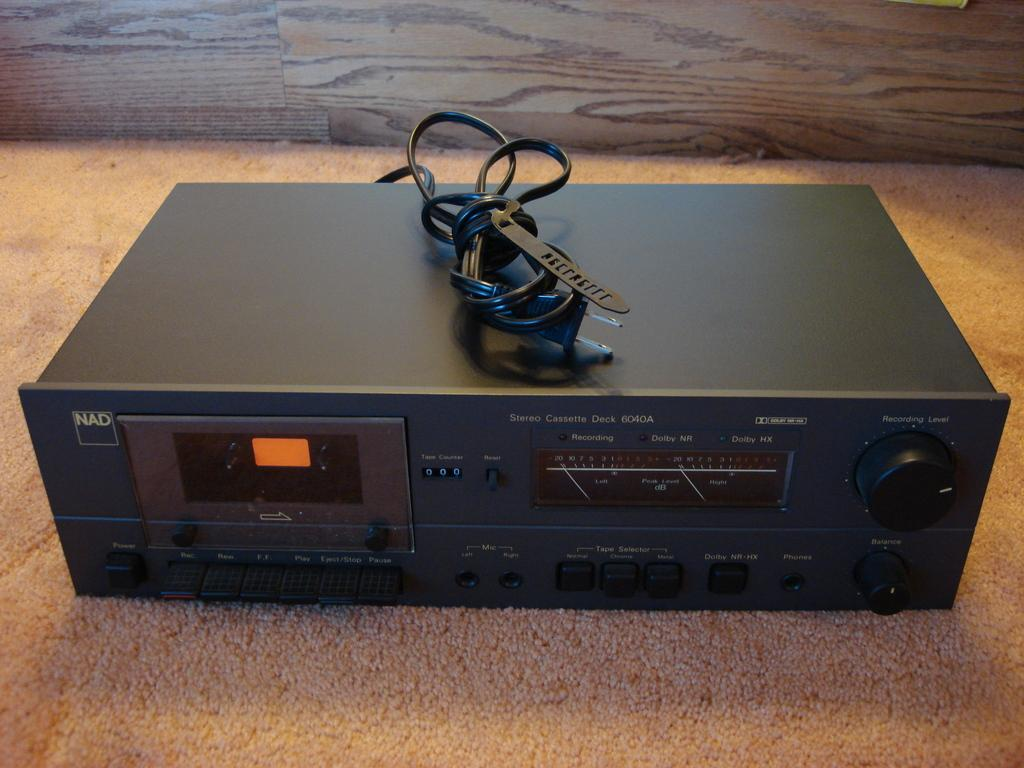What is the main subject of the image? There is an object on a mat in the image. Can you describe the object on the mat? Unfortunately, the facts provided do not give any details about the object on the mat. What can be seen in the background of the image? There is a wall in the background of the image. How many people are swimming under the bridge in the image? There is no bridge or swimming activity present in the image. What type of yoke is being used by the animals in the image? There are no animals or yokes present in the image. 